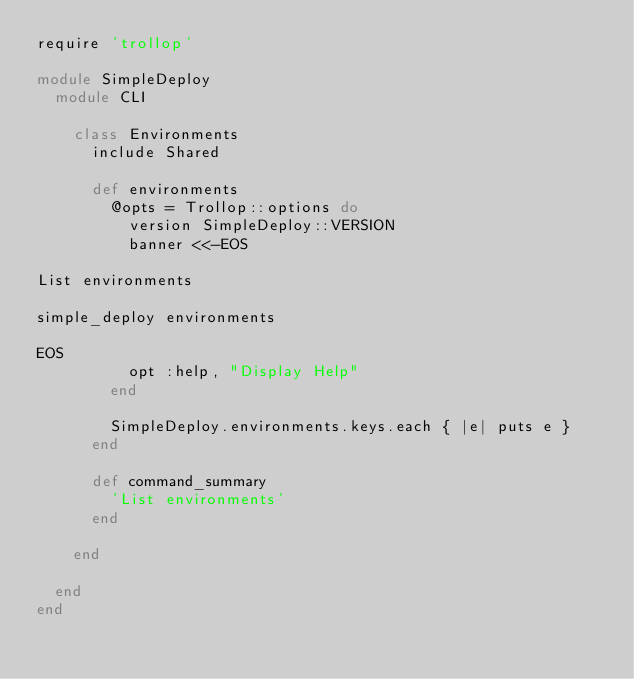Convert code to text. <code><loc_0><loc_0><loc_500><loc_500><_Ruby_>require 'trollop'

module SimpleDeploy
  module CLI

    class Environments
      include Shared

      def environments
        @opts = Trollop::options do
          version SimpleDeploy::VERSION
          banner <<-EOS

List environments

simple_deploy environments

EOS
          opt :help, "Display Help"
        end

        SimpleDeploy.environments.keys.each { |e| puts e }
      end

      def command_summary
        'List environments'
      end

    end

  end
end
</code> 